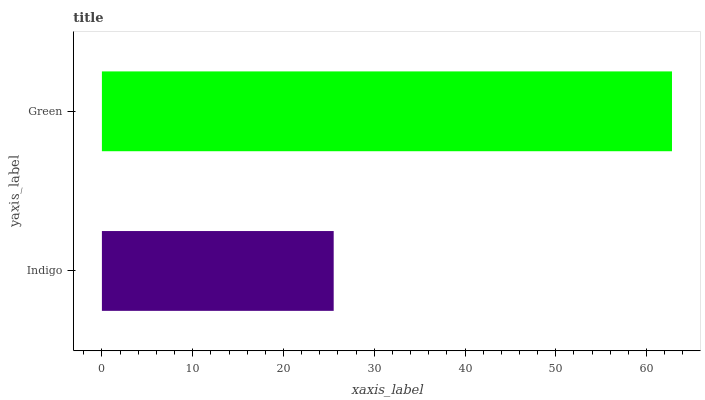Is Indigo the minimum?
Answer yes or no. Yes. Is Green the maximum?
Answer yes or no. Yes. Is Green the minimum?
Answer yes or no. No. Is Green greater than Indigo?
Answer yes or no. Yes. Is Indigo less than Green?
Answer yes or no. Yes. Is Indigo greater than Green?
Answer yes or no. No. Is Green less than Indigo?
Answer yes or no. No. Is Green the high median?
Answer yes or no. Yes. Is Indigo the low median?
Answer yes or no. Yes. Is Indigo the high median?
Answer yes or no. No. Is Green the low median?
Answer yes or no. No. 